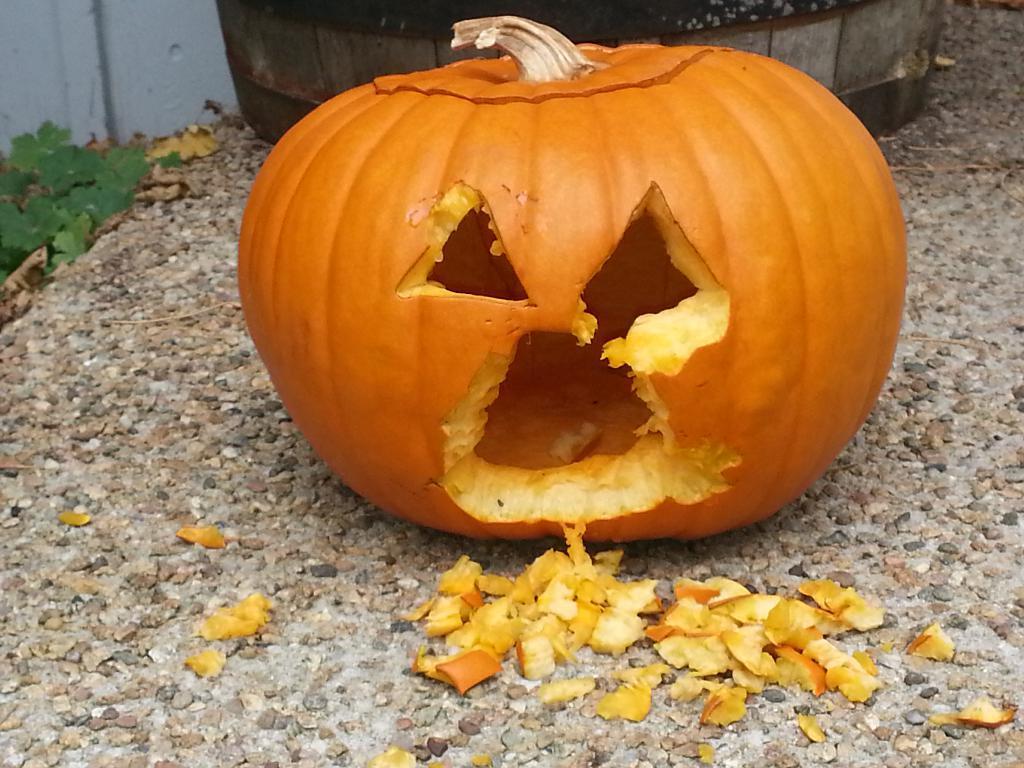In one or two sentences, can you explain what this image depicts? In this picture we can see a pumpkin, stones on the ground and in the background we can see an object, leaves and the wall. 